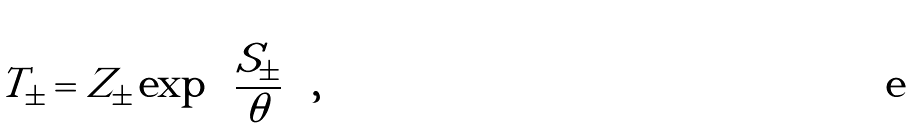<formula> <loc_0><loc_0><loc_500><loc_500>T _ { \pm } = Z _ { \pm } \exp \left ( \frac { S _ { \pm } } { \theta } \right ) ,</formula> 